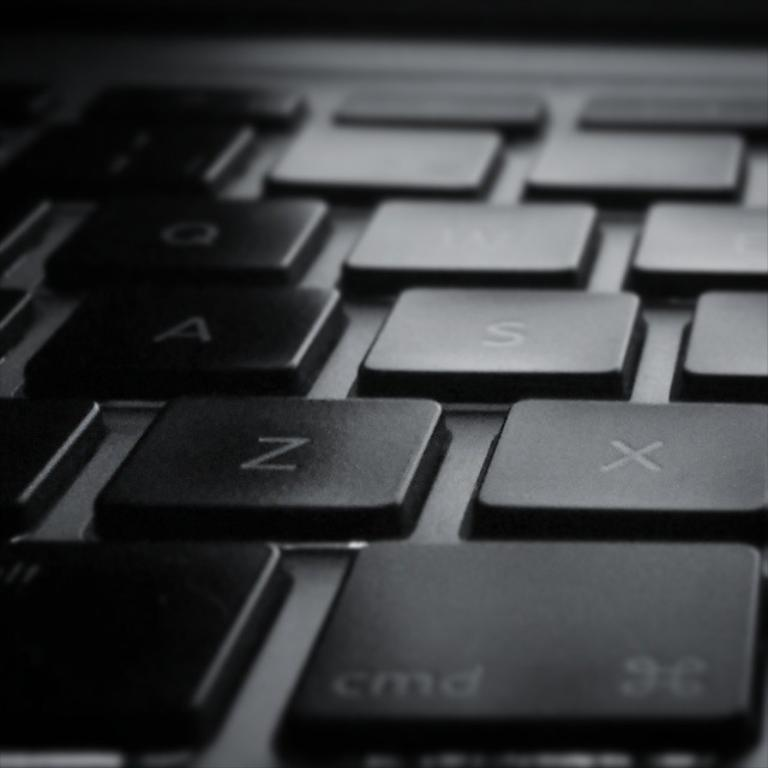<image>
Summarize the visual content of the image. A close up of a black keyboard with Z and X keys prominent. 